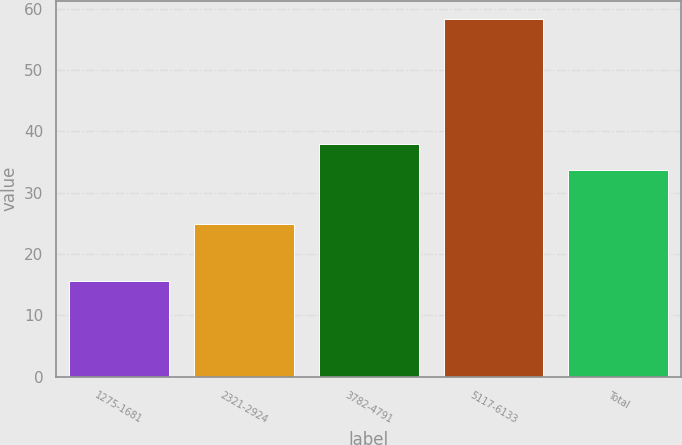Convert chart. <chart><loc_0><loc_0><loc_500><loc_500><bar_chart><fcel>1275-1681<fcel>2321-2924<fcel>3782-4791<fcel>5117-6133<fcel>Total<nl><fcel>15.56<fcel>24.9<fcel>37.98<fcel>58.38<fcel>33.7<nl></chart> 